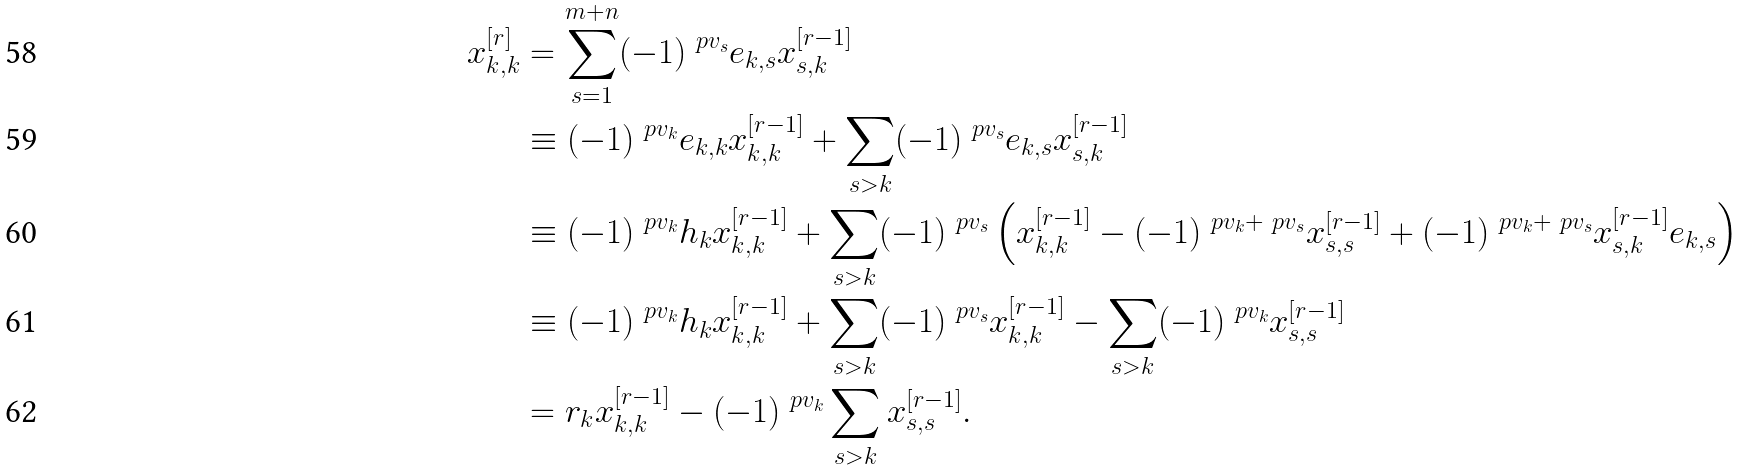<formula> <loc_0><loc_0><loc_500><loc_500>x _ { k , k } ^ { [ r ] } & = \sum _ { s = 1 } ^ { m + n } ( - 1 ) ^ { \ p { v } _ { s } } e _ { k , s } x _ { s , k } ^ { [ r - 1 ] } \\ & \equiv ( - 1 ) ^ { \ p { v } _ { k } } e _ { k , k } x _ { k , k } ^ { [ r - 1 ] } + \sum _ { s > k } ( - 1 ) ^ { \ p { v } _ { s } } e _ { k , s } x _ { s , k } ^ { [ r - 1 ] } \\ & \equiv ( - 1 ) ^ { \ p { v } _ { k } } h _ { k } x _ { k , k } ^ { [ r - 1 ] } + \sum _ { s > k } ( - 1 ) ^ { \ p { v } _ { s } } \left ( x _ { k , k } ^ { [ r - 1 ] } - ( - 1 ) ^ { \ p { v } _ { k } + \ p { v } _ { s } } x _ { s , s } ^ { [ r - 1 ] } + ( - 1 ) ^ { \ p { v } _ { k } + \ p { v } _ { s } } x _ { s , k } ^ { [ r - 1 ] } e _ { k , s } \right ) \\ & \equiv ( - 1 ) ^ { \ p { v } _ { k } } h _ { k } x _ { k , k } ^ { [ r - 1 ] } + \sum _ { s > k } ( - 1 ) ^ { \ p { v } _ { s } } x _ { k , k } ^ { [ r - 1 ] } - \sum _ { s > k } ( - 1 ) ^ { \ p { v } _ { k } } x _ { s , s } ^ { [ r - 1 ] } \\ & = r _ { k } x _ { k , k } ^ { [ r - 1 ] } - ( - 1 ) ^ { \ p { v } _ { k } } \sum _ { s > k } x _ { s , s } ^ { [ r - 1 ] } .</formula> 